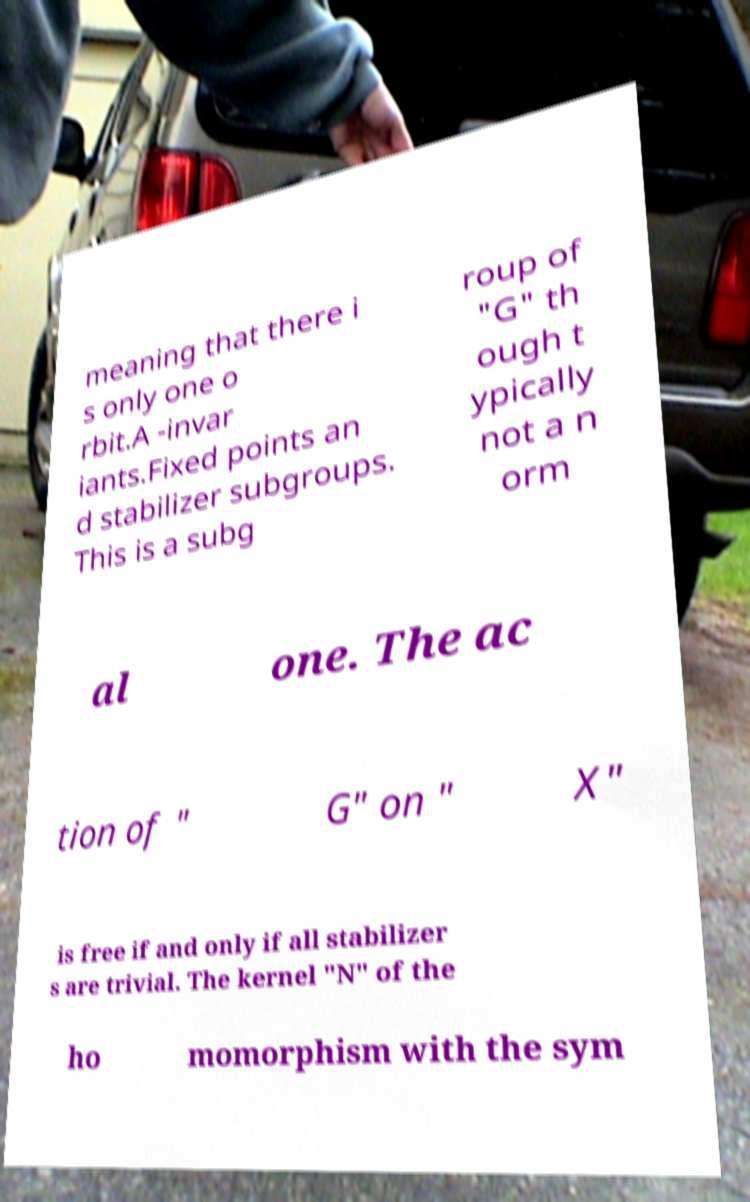Could you assist in decoding the text presented in this image and type it out clearly? meaning that there i s only one o rbit.A -invar iants.Fixed points an d stabilizer subgroups. This is a subg roup of "G" th ough t ypically not a n orm al one. The ac tion of " G" on " X" is free if and only if all stabilizer s are trivial. The kernel "N" of the ho momorphism with the sym 